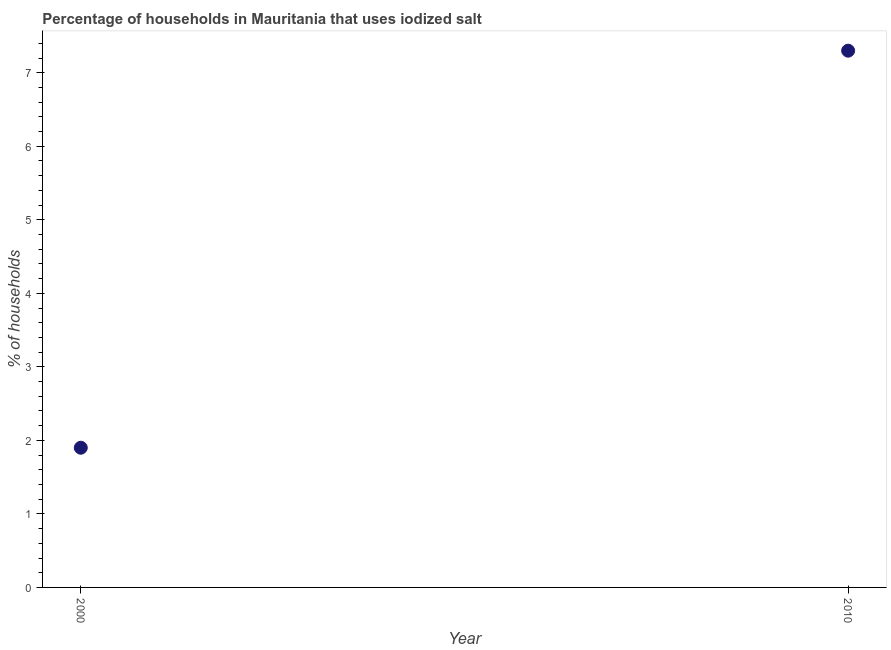What is the percentage of households where iodized salt is consumed in 2000?
Make the answer very short. 1.9. Across all years, what is the minimum percentage of households where iodized salt is consumed?
Offer a very short reply. 1.9. In which year was the percentage of households where iodized salt is consumed maximum?
Your answer should be compact. 2010. In which year was the percentage of households where iodized salt is consumed minimum?
Provide a short and direct response. 2000. What is the difference between the percentage of households where iodized salt is consumed in 2000 and 2010?
Make the answer very short. -5.4. What is the average percentage of households where iodized salt is consumed per year?
Your answer should be compact. 4.6. In how many years, is the percentage of households where iodized salt is consumed greater than 6.6 %?
Give a very brief answer. 1. What is the ratio of the percentage of households where iodized salt is consumed in 2000 to that in 2010?
Keep it short and to the point. 0.26. In how many years, is the percentage of households where iodized salt is consumed greater than the average percentage of households where iodized salt is consumed taken over all years?
Offer a very short reply. 1. How many dotlines are there?
Your response must be concise. 1. How many years are there in the graph?
Give a very brief answer. 2. Are the values on the major ticks of Y-axis written in scientific E-notation?
Keep it short and to the point. No. Does the graph contain grids?
Make the answer very short. No. What is the title of the graph?
Your answer should be very brief. Percentage of households in Mauritania that uses iodized salt. What is the label or title of the Y-axis?
Your response must be concise. % of households. What is the % of households in 2010?
Provide a short and direct response. 7.3. What is the ratio of the % of households in 2000 to that in 2010?
Provide a succinct answer. 0.26. 